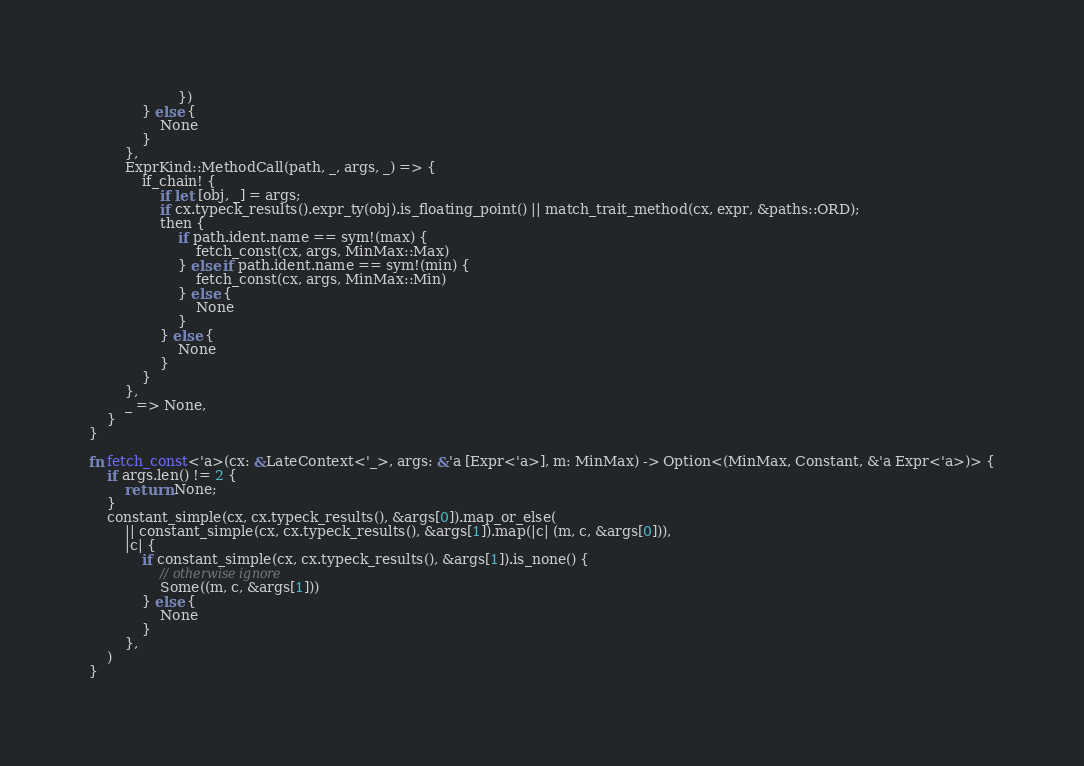Convert code to text. <code><loc_0><loc_0><loc_500><loc_500><_Rust_>                    })
            } else {
                None
            }
        },
        ExprKind::MethodCall(path, _, args, _) => {
            if_chain! {
                if let [obj, _] = args;
                if cx.typeck_results().expr_ty(obj).is_floating_point() || match_trait_method(cx, expr, &paths::ORD);
                then {
                    if path.ident.name == sym!(max) {
                        fetch_const(cx, args, MinMax::Max)
                    } else if path.ident.name == sym!(min) {
                        fetch_const(cx, args, MinMax::Min)
                    } else {
                        None
                    }
                } else {
                    None
                }
            }
        },
        _ => None,
    }
}

fn fetch_const<'a>(cx: &LateContext<'_>, args: &'a [Expr<'a>], m: MinMax) -> Option<(MinMax, Constant, &'a Expr<'a>)> {
    if args.len() != 2 {
        return None;
    }
    constant_simple(cx, cx.typeck_results(), &args[0]).map_or_else(
        || constant_simple(cx, cx.typeck_results(), &args[1]).map(|c| (m, c, &args[0])),
        |c| {
            if constant_simple(cx, cx.typeck_results(), &args[1]).is_none() {
                // otherwise ignore
                Some((m, c, &args[1]))
            } else {
                None
            }
        },
    )
}
</code> 